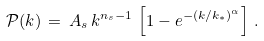Convert formula to latex. <formula><loc_0><loc_0><loc_500><loc_500>\mathcal { P } ( k ) \, = \, A _ { s } \, k ^ { n _ { s } - 1 } \, \left [ 1 - e ^ { - ( k / k _ { * } ) ^ { \alpha } } \right ] \, .</formula> 